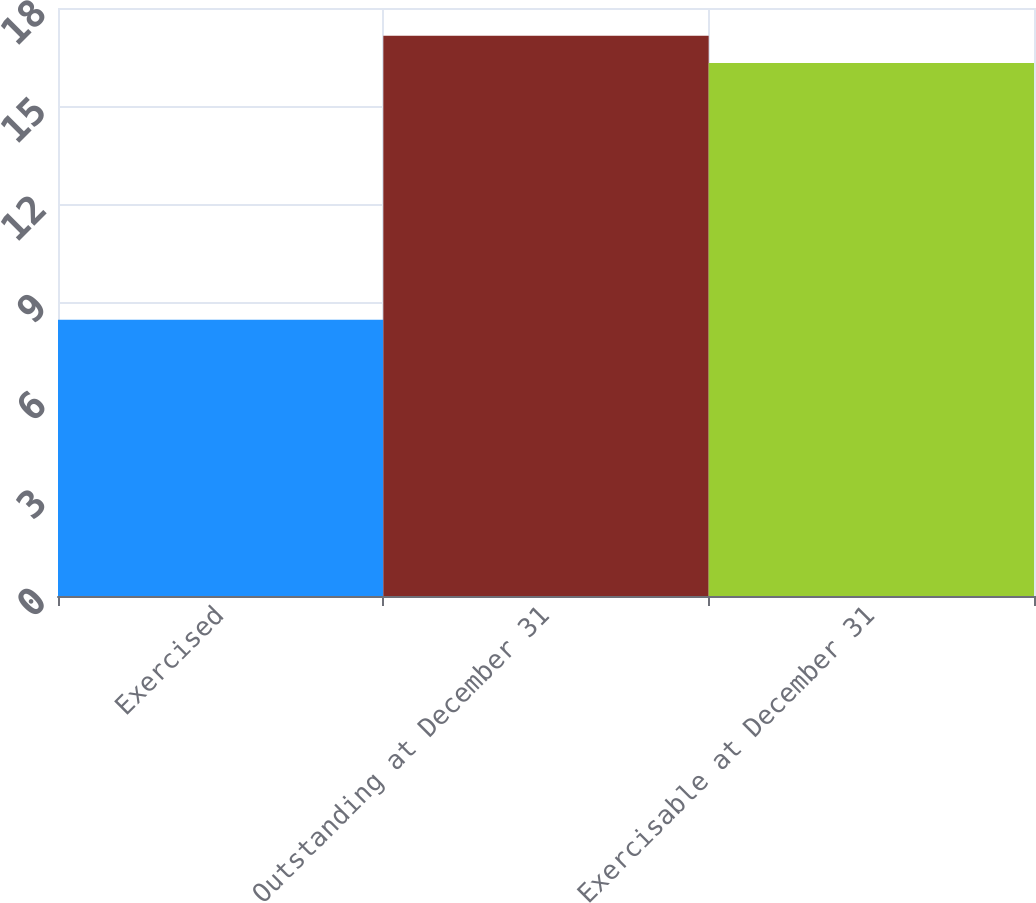<chart> <loc_0><loc_0><loc_500><loc_500><bar_chart><fcel>Exercised<fcel>Outstanding at December 31<fcel>Exercisable at December 31<nl><fcel>8.46<fcel>17.15<fcel>16.32<nl></chart> 